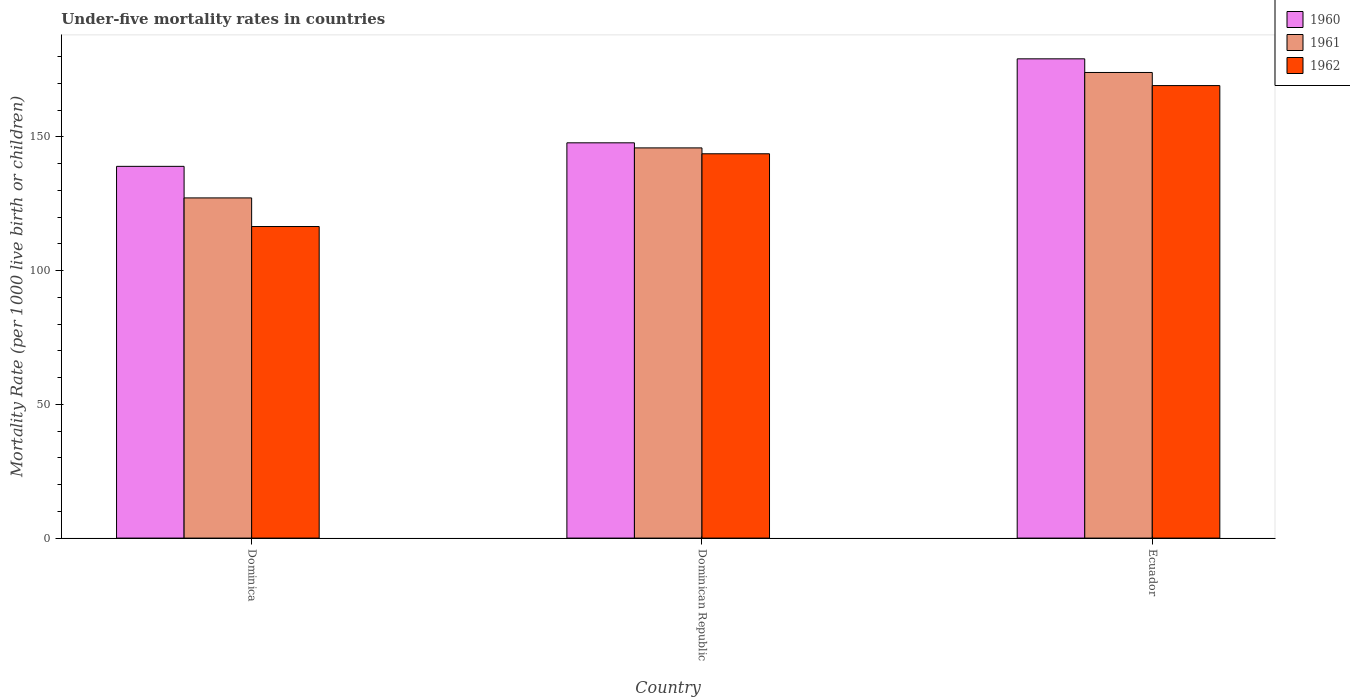How many different coloured bars are there?
Provide a succinct answer. 3. How many groups of bars are there?
Offer a terse response. 3. What is the label of the 2nd group of bars from the left?
Ensure brevity in your answer.  Dominican Republic. What is the under-five mortality rate in 1961 in Ecuador?
Offer a terse response. 174.1. Across all countries, what is the maximum under-five mortality rate in 1961?
Your answer should be very brief. 174.1. Across all countries, what is the minimum under-five mortality rate in 1961?
Provide a succinct answer. 127.2. In which country was the under-five mortality rate in 1960 maximum?
Your answer should be very brief. Ecuador. In which country was the under-five mortality rate in 1961 minimum?
Your answer should be compact. Dominica. What is the total under-five mortality rate in 1960 in the graph?
Give a very brief answer. 466. What is the difference between the under-five mortality rate in 1962 in Dominican Republic and that in Ecuador?
Your answer should be compact. -25.5. What is the difference between the under-five mortality rate in 1961 in Ecuador and the under-five mortality rate in 1960 in Dominican Republic?
Give a very brief answer. 26.3. What is the average under-five mortality rate in 1960 per country?
Provide a short and direct response. 155.33. What is the difference between the under-five mortality rate of/in 1962 and under-five mortality rate of/in 1960 in Dominican Republic?
Ensure brevity in your answer.  -4.1. What is the ratio of the under-five mortality rate in 1960 in Dominican Republic to that in Ecuador?
Offer a terse response. 0.82. What is the difference between the highest and the second highest under-five mortality rate in 1960?
Offer a terse response. 31.4. What is the difference between the highest and the lowest under-five mortality rate in 1961?
Offer a very short reply. 46.9. In how many countries, is the under-five mortality rate in 1962 greater than the average under-five mortality rate in 1962 taken over all countries?
Your answer should be very brief. 2. Is the sum of the under-five mortality rate in 1961 in Dominican Republic and Ecuador greater than the maximum under-five mortality rate in 1962 across all countries?
Your answer should be compact. Yes. What does the 2nd bar from the left in Ecuador represents?
Keep it short and to the point. 1961. How many countries are there in the graph?
Offer a very short reply. 3. Does the graph contain grids?
Offer a terse response. No. What is the title of the graph?
Your answer should be very brief. Under-five mortality rates in countries. What is the label or title of the X-axis?
Make the answer very short. Country. What is the label or title of the Y-axis?
Make the answer very short. Mortality Rate (per 1000 live birth or children). What is the Mortality Rate (per 1000 live birth or children) in 1960 in Dominica?
Offer a very short reply. 139. What is the Mortality Rate (per 1000 live birth or children) of 1961 in Dominica?
Give a very brief answer. 127.2. What is the Mortality Rate (per 1000 live birth or children) of 1962 in Dominica?
Provide a succinct answer. 116.5. What is the Mortality Rate (per 1000 live birth or children) of 1960 in Dominican Republic?
Your response must be concise. 147.8. What is the Mortality Rate (per 1000 live birth or children) of 1961 in Dominican Republic?
Your answer should be compact. 145.9. What is the Mortality Rate (per 1000 live birth or children) of 1962 in Dominican Republic?
Ensure brevity in your answer.  143.7. What is the Mortality Rate (per 1000 live birth or children) of 1960 in Ecuador?
Offer a very short reply. 179.2. What is the Mortality Rate (per 1000 live birth or children) in 1961 in Ecuador?
Make the answer very short. 174.1. What is the Mortality Rate (per 1000 live birth or children) of 1962 in Ecuador?
Keep it short and to the point. 169.2. Across all countries, what is the maximum Mortality Rate (per 1000 live birth or children) in 1960?
Provide a short and direct response. 179.2. Across all countries, what is the maximum Mortality Rate (per 1000 live birth or children) of 1961?
Offer a terse response. 174.1. Across all countries, what is the maximum Mortality Rate (per 1000 live birth or children) in 1962?
Provide a succinct answer. 169.2. Across all countries, what is the minimum Mortality Rate (per 1000 live birth or children) of 1960?
Ensure brevity in your answer.  139. Across all countries, what is the minimum Mortality Rate (per 1000 live birth or children) of 1961?
Your response must be concise. 127.2. Across all countries, what is the minimum Mortality Rate (per 1000 live birth or children) of 1962?
Keep it short and to the point. 116.5. What is the total Mortality Rate (per 1000 live birth or children) in 1960 in the graph?
Give a very brief answer. 466. What is the total Mortality Rate (per 1000 live birth or children) in 1961 in the graph?
Provide a short and direct response. 447.2. What is the total Mortality Rate (per 1000 live birth or children) in 1962 in the graph?
Provide a short and direct response. 429.4. What is the difference between the Mortality Rate (per 1000 live birth or children) of 1960 in Dominica and that in Dominican Republic?
Give a very brief answer. -8.8. What is the difference between the Mortality Rate (per 1000 live birth or children) of 1961 in Dominica and that in Dominican Republic?
Your response must be concise. -18.7. What is the difference between the Mortality Rate (per 1000 live birth or children) of 1962 in Dominica and that in Dominican Republic?
Your answer should be compact. -27.2. What is the difference between the Mortality Rate (per 1000 live birth or children) in 1960 in Dominica and that in Ecuador?
Keep it short and to the point. -40.2. What is the difference between the Mortality Rate (per 1000 live birth or children) in 1961 in Dominica and that in Ecuador?
Your answer should be compact. -46.9. What is the difference between the Mortality Rate (per 1000 live birth or children) in 1962 in Dominica and that in Ecuador?
Keep it short and to the point. -52.7. What is the difference between the Mortality Rate (per 1000 live birth or children) in 1960 in Dominican Republic and that in Ecuador?
Your answer should be compact. -31.4. What is the difference between the Mortality Rate (per 1000 live birth or children) of 1961 in Dominican Republic and that in Ecuador?
Provide a succinct answer. -28.2. What is the difference between the Mortality Rate (per 1000 live birth or children) in 1962 in Dominican Republic and that in Ecuador?
Provide a succinct answer. -25.5. What is the difference between the Mortality Rate (per 1000 live birth or children) in 1960 in Dominica and the Mortality Rate (per 1000 live birth or children) in 1962 in Dominican Republic?
Provide a short and direct response. -4.7. What is the difference between the Mortality Rate (per 1000 live birth or children) of 1961 in Dominica and the Mortality Rate (per 1000 live birth or children) of 1962 in Dominican Republic?
Give a very brief answer. -16.5. What is the difference between the Mortality Rate (per 1000 live birth or children) in 1960 in Dominica and the Mortality Rate (per 1000 live birth or children) in 1961 in Ecuador?
Make the answer very short. -35.1. What is the difference between the Mortality Rate (per 1000 live birth or children) of 1960 in Dominica and the Mortality Rate (per 1000 live birth or children) of 1962 in Ecuador?
Offer a terse response. -30.2. What is the difference between the Mortality Rate (per 1000 live birth or children) in 1961 in Dominica and the Mortality Rate (per 1000 live birth or children) in 1962 in Ecuador?
Your answer should be very brief. -42. What is the difference between the Mortality Rate (per 1000 live birth or children) in 1960 in Dominican Republic and the Mortality Rate (per 1000 live birth or children) in 1961 in Ecuador?
Your response must be concise. -26.3. What is the difference between the Mortality Rate (per 1000 live birth or children) of 1960 in Dominican Republic and the Mortality Rate (per 1000 live birth or children) of 1962 in Ecuador?
Make the answer very short. -21.4. What is the difference between the Mortality Rate (per 1000 live birth or children) of 1961 in Dominican Republic and the Mortality Rate (per 1000 live birth or children) of 1962 in Ecuador?
Your response must be concise. -23.3. What is the average Mortality Rate (per 1000 live birth or children) in 1960 per country?
Offer a very short reply. 155.33. What is the average Mortality Rate (per 1000 live birth or children) in 1961 per country?
Keep it short and to the point. 149.07. What is the average Mortality Rate (per 1000 live birth or children) of 1962 per country?
Offer a terse response. 143.13. What is the difference between the Mortality Rate (per 1000 live birth or children) in 1960 and Mortality Rate (per 1000 live birth or children) in 1961 in Dominica?
Offer a terse response. 11.8. What is the difference between the Mortality Rate (per 1000 live birth or children) of 1960 and Mortality Rate (per 1000 live birth or children) of 1962 in Dominica?
Offer a very short reply. 22.5. What is the difference between the Mortality Rate (per 1000 live birth or children) in 1960 and Mortality Rate (per 1000 live birth or children) in 1961 in Dominican Republic?
Your response must be concise. 1.9. What is the difference between the Mortality Rate (per 1000 live birth or children) of 1960 and Mortality Rate (per 1000 live birth or children) of 1961 in Ecuador?
Your answer should be very brief. 5.1. What is the difference between the Mortality Rate (per 1000 live birth or children) of 1960 and Mortality Rate (per 1000 live birth or children) of 1962 in Ecuador?
Keep it short and to the point. 10. What is the difference between the Mortality Rate (per 1000 live birth or children) of 1961 and Mortality Rate (per 1000 live birth or children) of 1962 in Ecuador?
Provide a succinct answer. 4.9. What is the ratio of the Mortality Rate (per 1000 live birth or children) of 1960 in Dominica to that in Dominican Republic?
Offer a terse response. 0.94. What is the ratio of the Mortality Rate (per 1000 live birth or children) in 1961 in Dominica to that in Dominican Republic?
Give a very brief answer. 0.87. What is the ratio of the Mortality Rate (per 1000 live birth or children) of 1962 in Dominica to that in Dominican Republic?
Provide a short and direct response. 0.81. What is the ratio of the Mortality Rate (per 1000 live birth or children) of 1960 in Dominica to that in Ecuador?
Your answer should be very brief. 0.78. What is the ratio of the Mortality Rate (per 1000 live birth or children) in 1961 in Dominica to that in Ecuador?
Provide a succinct answer. 0.73. What is the ratio of the Mortality Rate (per 1000 live birth or children) of 1962 in Dominica to that in Ecuador?
Keep it short and to the point. 0.69. What is the ratio of the Mortality Rate (per 1000 live birth or children) of 1960 in Dominican Republic to that in Ecuador?
Provide a succinct answer. 0.82. What is the ratio of the Mortality Rate (per 1000 live birth or children) of 1961 in Dominican Republic to that in Ecuador?
Make the answer very short. 0.84. What is the ratio of the Mortality Rate (per 1000 live birth or children) of 1962 in Dominican Republic to that in Ecuador?
Provide a short and direct response. 0.85. What is the difference between the highest and the second highest Mortality Rate (per 1000 live birth or children) of 1960?
Provide a short and direct response. 31.4. What is the difference between the highest and the second highest Mortality Rate (per 1000 live birth or children) in 1961?
Keep it short and to the point. 28.2. What is the difference between the highest and the lowest Mortality Rate (per 1000 live birth or children) in 1960?
Make the answer very short. 40.2. What is the difference between the highest and the lowest Mortality Rate (per 1000 live birth or children) of 1961?
Provide a short and direct response. 46.9. What is the difference between the highest and the lowest Mortality Rate (per 1000 live birth or children) in 1962?
Ensure brevity in your answer.  52.7. 